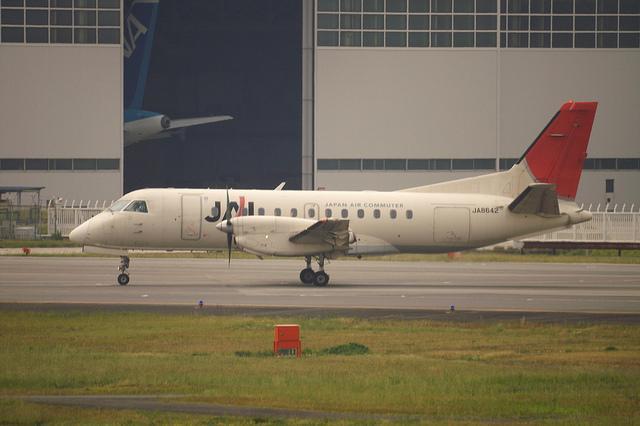How many engines can be seen at this angle?
Give a very brief answer. 1. How many skateboards are in the picture?
Give a very brief answer. 0. 